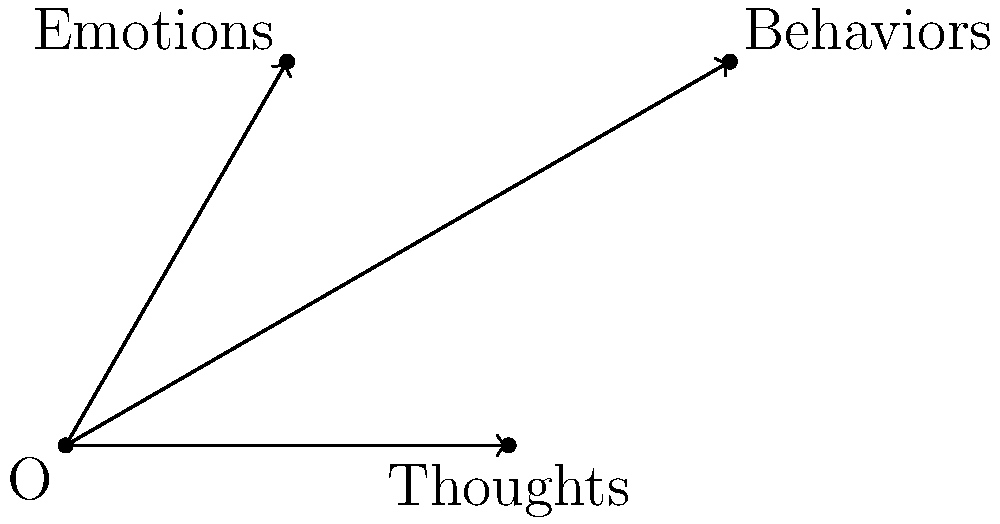In the context of cognitive behavioral therapy, the vector diagram above represents the interaction between thoughts, emotions, and behaviors. If we consider these components as vectors, which vector would represent the overall psychological state of a patient according to the principles of vector addition? To determine the overall psychological state using vector addition, we need to follow these steps:

1. Recognize that each component (thoughts, emotions, and behaviors) is represented by a vector starting from the origin O.

2. In vector addition, we combine vectors by placing the start of one vector at the end of another, continuing until all vectors are used.

3. The resultant vector, which represents the sum of all vectors, is drawn from the starting point (origin) to the endpoint of the last vector in the chain.

4. In this case, we need to add all three vectors: OA (thoughts), OB (emotions), and OC (behaviors).

5. The resultant vector OR would start at O and end at a point R, which would be the sum of the displacements of A, B, and C from O.

6. This resultant vector OR represents the overall psychological state, as it incorporates the combined effect of thoughts, emotions, and behaviors.

7. In cognitive behavioral therapy, this visualization helps patients understand how these components interact and influence their overall psychological state.

8. By modifying one or more of these components through therapy, the resultant vector (overall psychological state) can be changed.
Answer: The resultant vector OR (not shown in the diagram) representing the sum of thoughts, emotions, and behaviors vectors. 